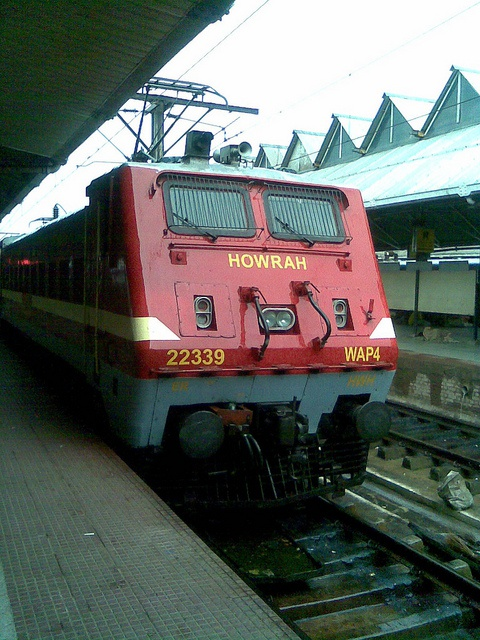Describe the objects in this image and their specific colors. I can see a train in black, gray, salmon, and teal tones in this image. 